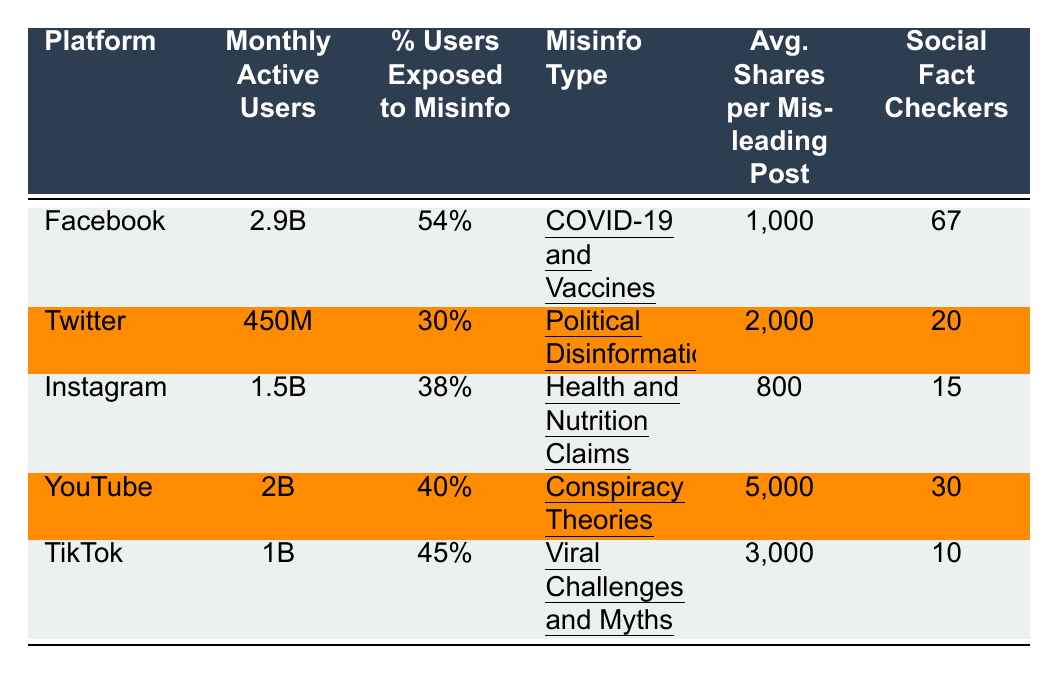What is the percentage of users exposed to misinformation on Facebook? The table shows that Facebook has 54% of its users exposed to misinformation.
Answer: 54% Which social media platform has the highest average shares per misleading post? From the table, YouTube has the highest average shares at 5,000 per misleading post.
Answer: YouTube How many total fact checkers are there across all platforms? The total number of social fact checkers is calculated by adding the individual numbers: 67 (Facebook) + 20 (Twitter) + 15 (Instagram) + 30 (YouTube) + 10 (TikTok) = 142.
Answer: 142 Which platform has the lowest percentage of users exposed to misinformation? By examining the percentages, Twitter has the lowest percentage of users exposed to misinformation at 30%.
Answer: Twitter Is the misinformation type with the highest average shares related to COVID-19? The misinformation type with the highest average shares is about conspiracy theories on YouTube, not COVID-19, which is associated with Facebook.
Answer: No What is the difference in monthly active users between TikTok and Twitter? TikTok has 1 billion monthly active users and Twitter has 450 million. The difference is calculated as 1000M - 450M = 550M.
Answer: 550 million On which platform is the percentage of users exposed to misinformation greater than 40%? Facebook, YouTube, and TikTok all have percentages greater than 40%, as evidenced in the table (54%, 40%, and 45% respectively).
Answer: Facebook, YouTube, TikTok What average shares per misleading post do Instagram users experience? The table specifies that Instagram users experience an average of 800 shares per misleading post.
Answer: 800 If we average the percentage of users exposed to misinformation across all platforms, what do we get? The average is calculated as follows: (54% + 30% + 38% + 40% + 45%) / 5 = 41.4%.
Answer: 41.4% In terms of the amount of misinformation type types, which platform is associated with health-related claims? The table shows that Instagram is associated with health and nutrition claims as its misinformation type.
Answer: Instagram 